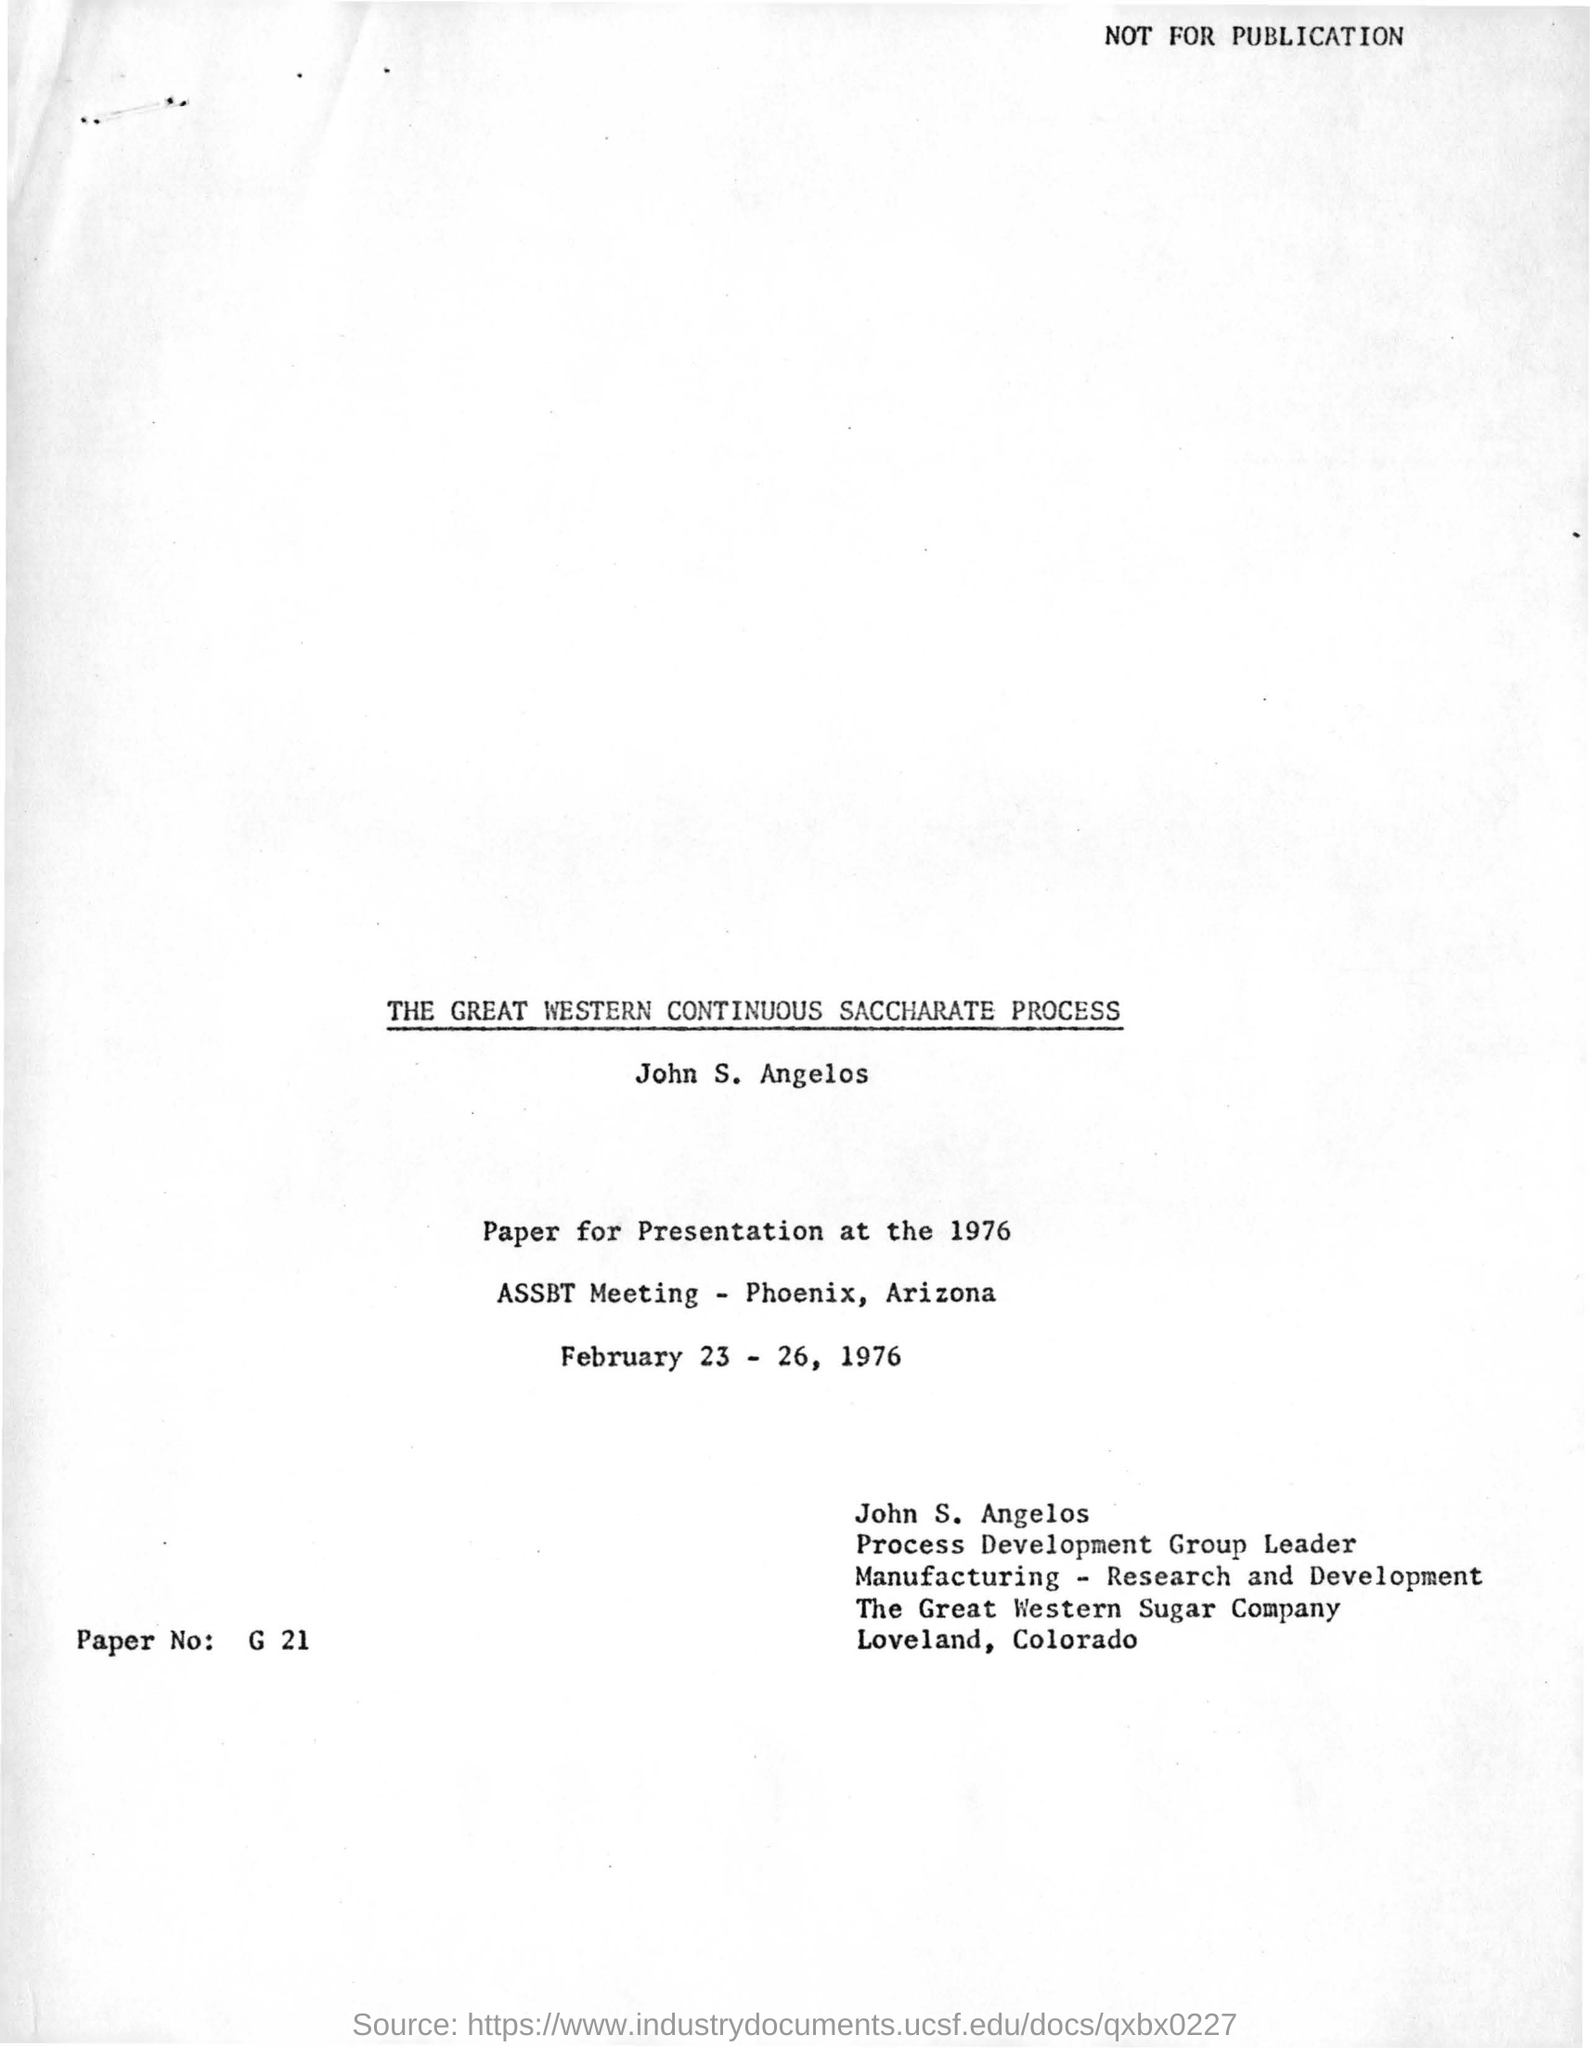Identify some key points in this picture. The location of the Great Western Sugar Company is in Loveland, Colorado. The title of the presentation by John S. Angelos is "The Great Western Continuous Saccharate Process. The location of the ASSBT meeting is in Phoenix, Arizona. The process development group leader is John S. Angelos. 